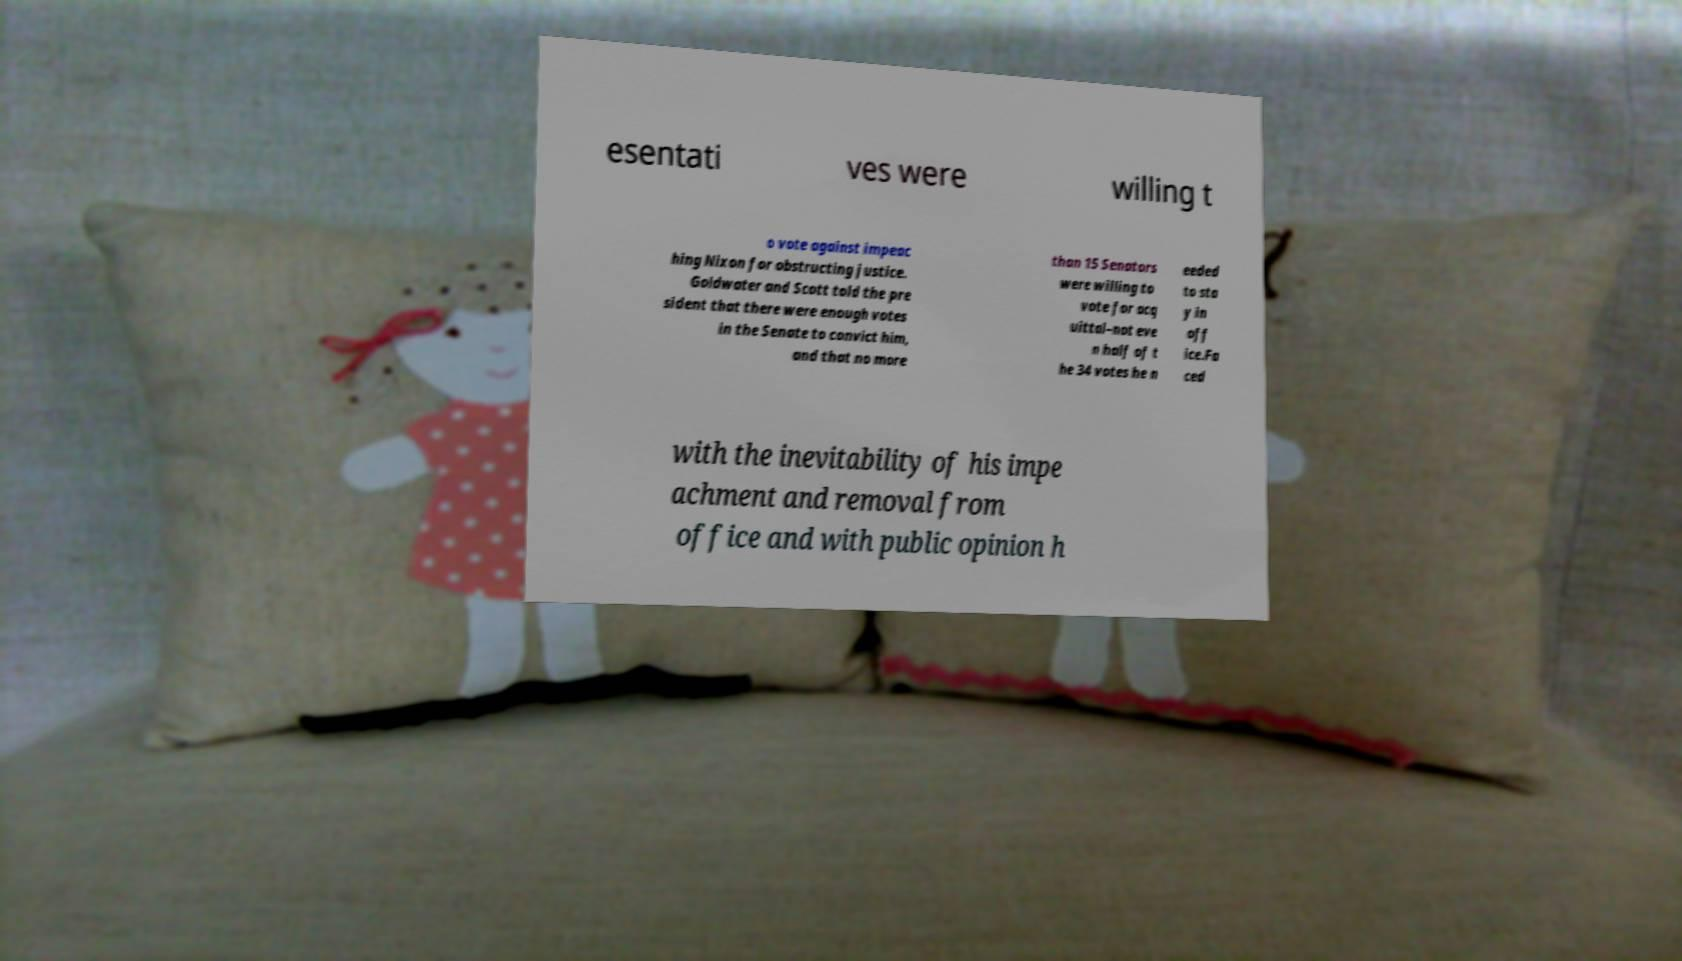Can you accurately transcribe the text from the provided image for me? esentati ves were willing t o vote against impeac hing Nixon for obstructing justice. Goldwater and Scott told the pre sident that there were enough votes in the Senate to convict him, and that no more than 15 Senators were willing to vote for acq uittal–not eve n half of t he 34 votes he n eeded to sta y in off ice.Fa ced with the inevitability of his impe achment and removal from office and with public opinion h 